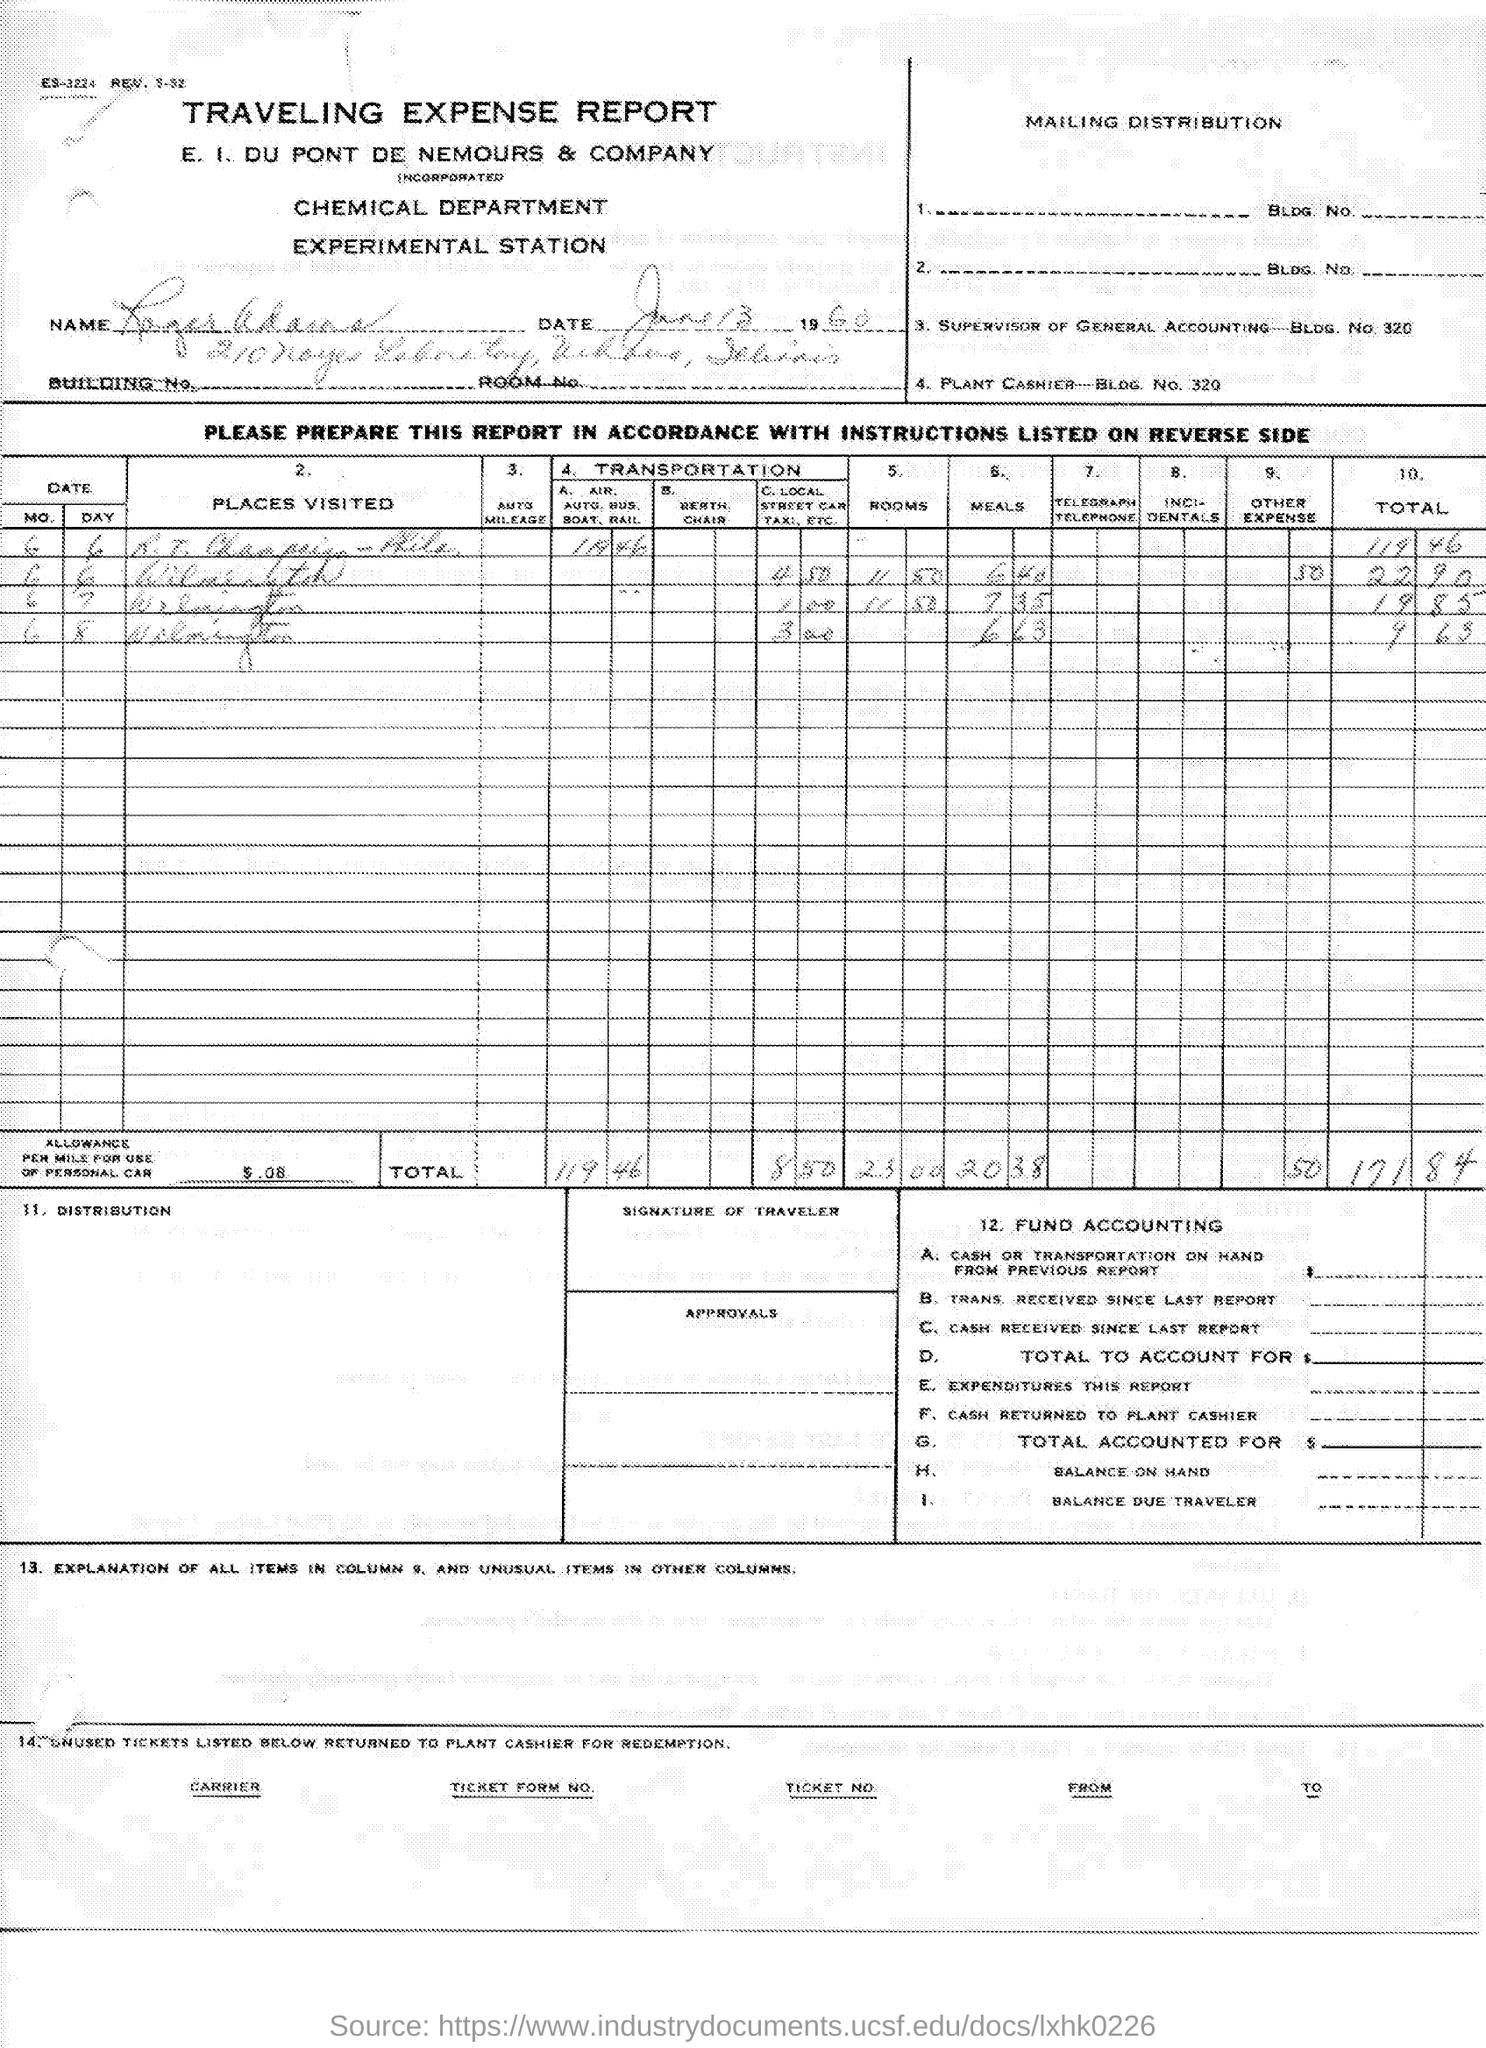What type of documentation is this?
Provide a succinct answer. TRAVELING EXPENSE REPORT. Which department is involved?
Provide a short and direct response. CHEMICAL DEPARTMENT. Which company's name is mentioned?
Make the answer very short. E. I. DU PONT DE NEMOURS & COMPANY. 